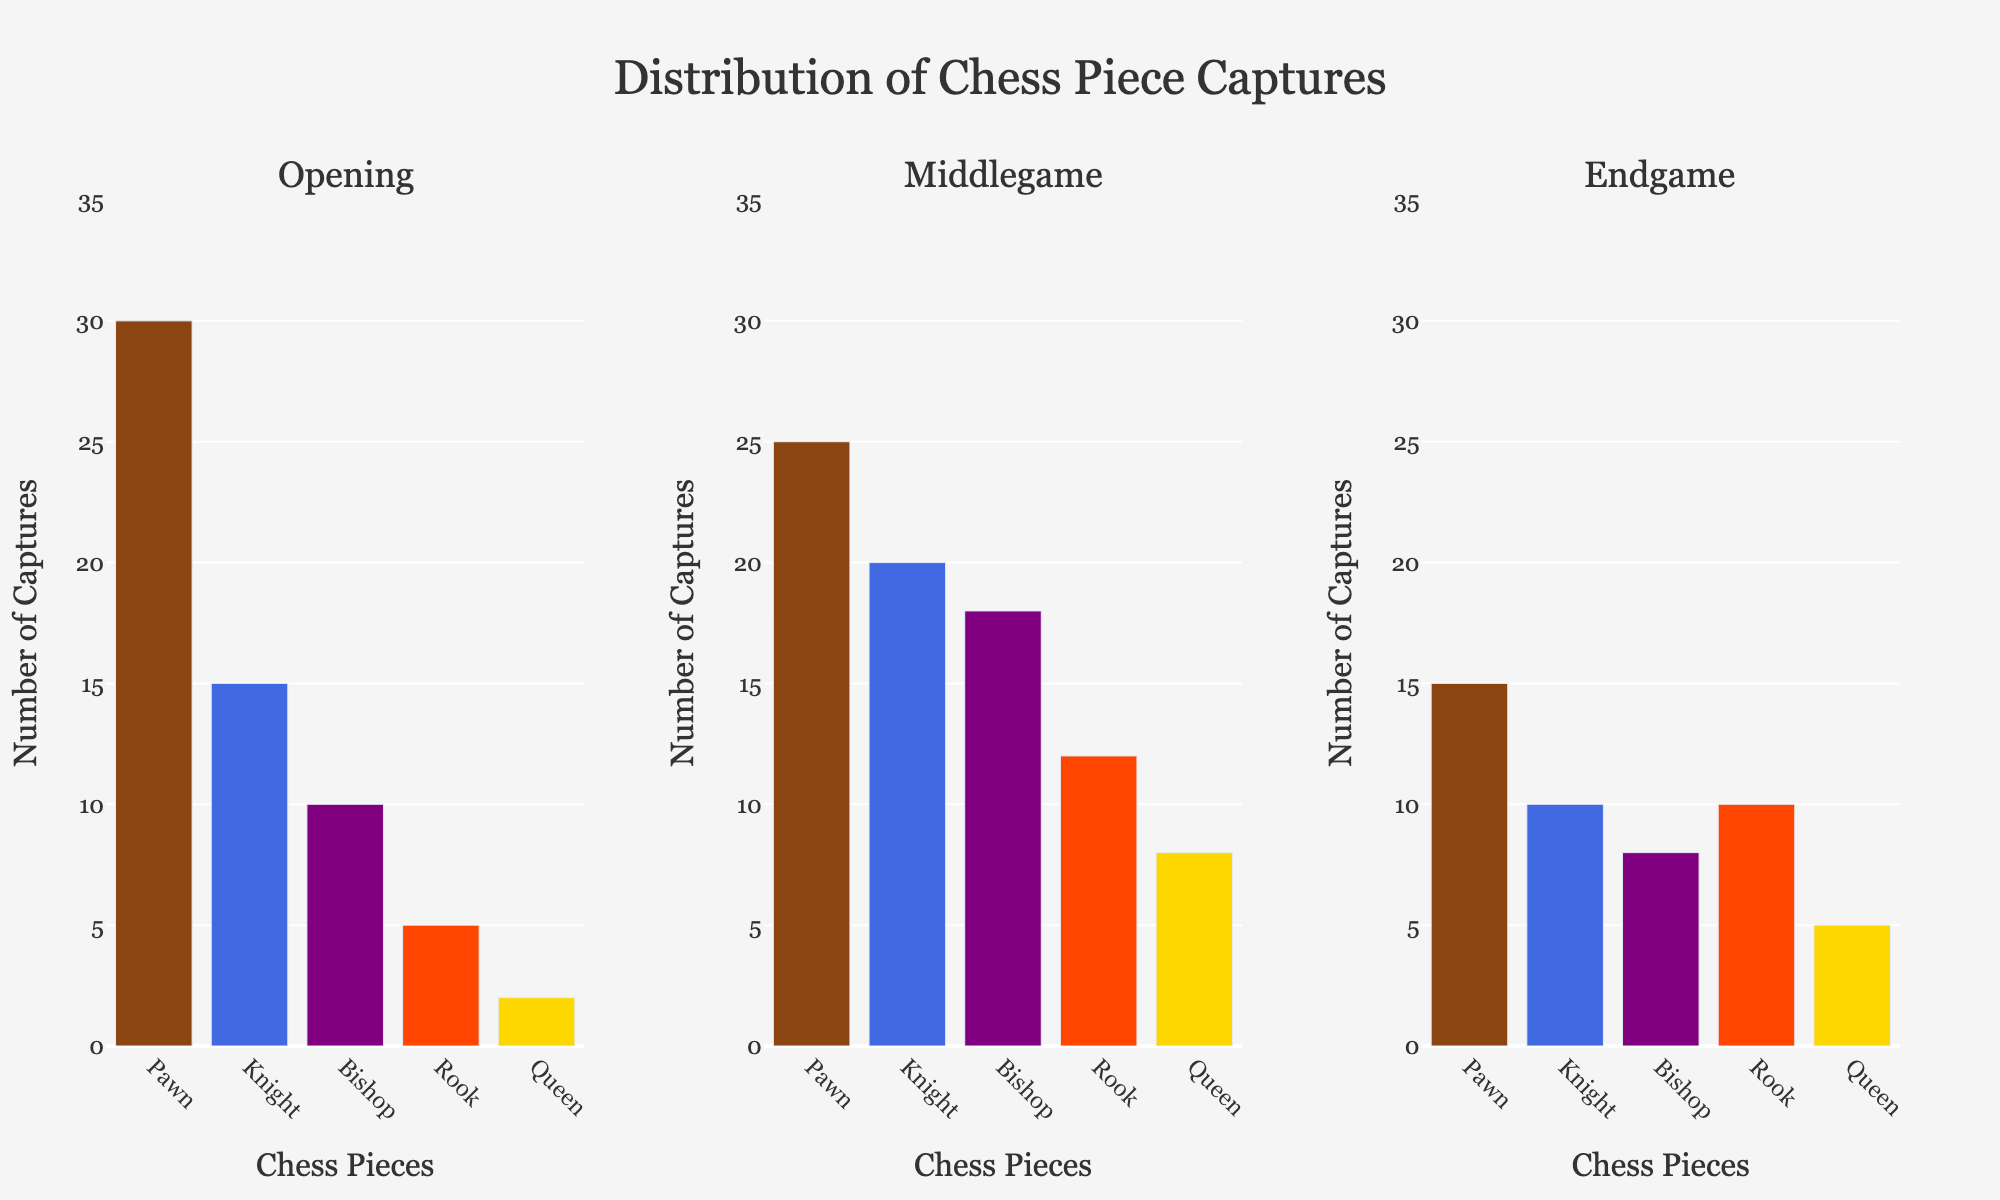What's the title of the figure? The title of the figure is located at the top and is typically centered. In this case, it reads: "Distribution of Chess Piece Captures".
Answer: Distribution of Chess Piece Captures What piece is captured the most during the opening phase? To determine which piece is captured the most during the opening phase, look at the first subplot under "Opening" and find the tallest bar. It corresponds to the "Pawn" with 30 captures.
Answer: Pawn How many captures are there in total for the Queen across all phases? Sum the values for the Queen in the opening, middlegame, and endgame phases. That's 2 (opening) + 8 (middlegame) + 5 (endgame) = 15.
Answer: 15 Which phase has the highest number of Knight captures? Compare the height of the bars corresponding to the "Knight" piece in all three subplots. The highest bar is the one under "Middlegame" with 20 captures.
Answer: Middlegame What is the difference in the number of Bishop captures between the endgame and the middlegame? Subtract the number of Bishop captures in the endgame (8) from those in the middlegame (18). So, 18 - 8 = 10.
Answer: 10 In which phase are Rook captures equal to Queen captures? Compare the bars for the "Rook" and "Queen" pieces in each phase. In the endgame, both Rook and Queen have 10 and 5 captures, respectively, so no phase meets this condition.
Answer: None What is the average number of pieces captured in the middlegame phase? Add up the number of captures for the Pawn (25), Knight (20), Bishop (18), Rook (12), and Queen (8) in the middlegame, then divide by 5. (25 + 20 + 18 + 12 + 8) / 5 = 83 / 5 = 16.6.
Answer: 16.6 Which phase has the lowest total number of captures? Calculate the total captures for each phase: Opening (30+15+10+5+2), Middlegame (25+20+18+12+8), and Endgame (15+10+8+10+5). The totals are 62 for Opening, 83 for Middlegame, and 48 for Endgame. The endgame phase has the lowest total captures.
Answer: Endgame By what percentage do Pawn captures decrease from opening to middlegame? Calculate the difference in Pawn captures between the opening (30) and middlegame (25), then divide by the opening captures and multiply by 100: ((30 - 25) / 30) * 100 = (5 / 30) * 100 ≈ 16.67%.
Answer: ~16.67% What's the combined total of all piece captures in the endgame phase? Add the number of captures for all pieces in the endgame: Pawn (15) + Knight (10) + Bishop (8) + Rook (10) + Queen (5). So, 15 + 10 + 8 + 10 + 5 = 48.
Answer: 48 